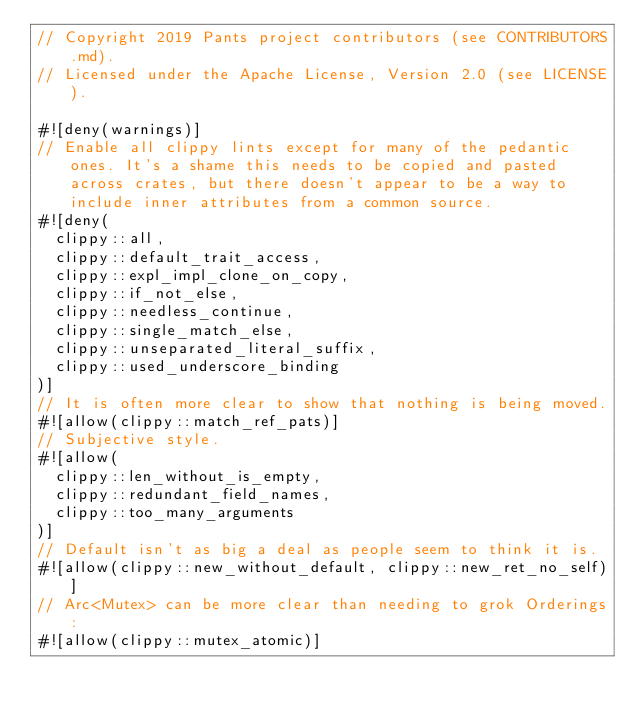<code> <loc_0><loc_0><loc_500><loc_500><_Rust_>// Copyright 2019 Pants project contributors (see CONTRIBUTORS.md).
// Licensed under the Apache License, Version 2.0 (see LICENSE).

#![deny(warnings)]
// Enable all clippy lints except for many of the pedantic ones. It's a shame this needs to be copied and pasted across crates, but there doesn't appear to be a way to include inner attributes from a common source.
#![deny(
  clippy::all,
  clippy::default_trait_access,
  clippy::expl_impl_clone_on_copy,
  clippy::if_not_else,
  clippy::needless_continue,
  clippy::single_match_else,
  clippy::unseparated_literal_suffix,
  clippy::used_underscore_binding
)]
// It is often more clear to show that nothing is being moved.
#![allow(clippy::match_ref_pats)]
// Subjective style.
#![allow(
  clippy::len_without_is_empty,
  clippy::redundant_field_names,
  clippy::too_many_arguments
)]
// Default isn't as big a deal as people seem to think it is.
#![allow(clippy::new_without_default, clippy::new_ret_no_self)]
// Arc<Mutex> can be more clear than needing to grok Orderings:
#![allow(clippy::mutex_atomic)]
</code> 